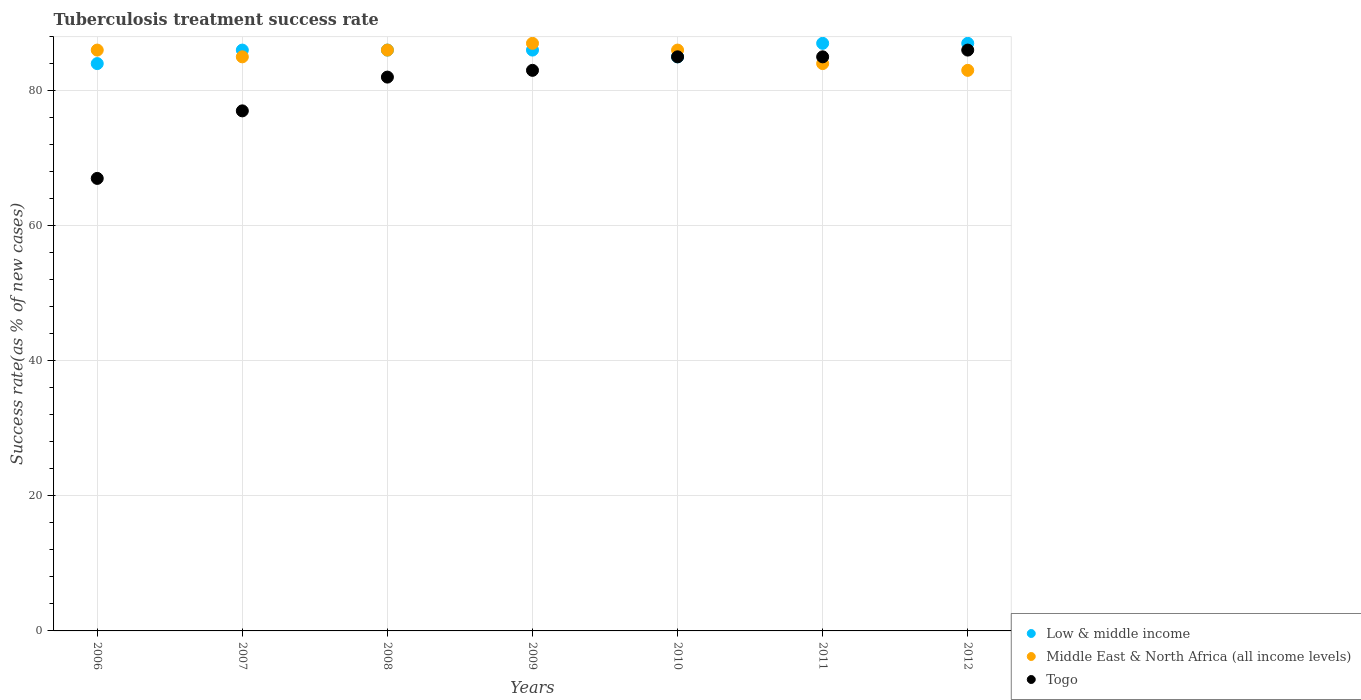How many different coloured dotlines are there?
Ensure brevity in your answer.  3. Is the number of dotlines equal to the number of legend labels?
Offer a very short reply. Yes. What is the tuberculosis treatment success rate in Low & middle income in 2012?
Keep it short and to the point. 87. Across all years, what is the maximum tuberculosis treatment success rate in Low & middle income?
Offer a terse response. 87. Across all years, what is the minimum tuberculosis treatment success rate in Low & middle income?
Provide a succinct answer. 84. In which year was the tuberculosis treatment success rate in Togo maximum?
Your answer should be very brief. 2012. In which year was the tuberculosis treatment success rate in Togo minimum?
Keep it short and to the point. 2006. What is the total tuberculosis treatment success rate in Middle East & North Africa (all income levels) in the graph?
Keep it short and to the point. 597. What is the difference between the tuberculosis treatment success rate in Middle East & North Africa (all income levels) in 2010 and that in 2012?
Your answer should be very brief. 3. What is the average tuberculosis treatment success rate in Togo per year?
Your answer should be very brief. 80.71. In the year 2006, what is the difference between the tuberculosis treatment success rate in Low & middle income and tuberculosis treatment success rate in Middle East & North Africa (all income levels)?
Your response must be concise. -2. In how many years, is the tuberculosis treatment success rate in Middle East & North Africa (all income levels) greater than 8 %?
Offer a very short reply. 7. What is the ratio of the tuberculosis treatment success rate in Togo in 2006 to that in 2012?
Your response must be concise. 0.78. Is the difference between the tuberculosis treatment success rate in Low & middle income in 2009 and 2012 greater than the difference between the tuberculosis treatment success rate in Middle East & North Africa (all income levels) in 2009 and 2012?
Give a very brief answer. No. What is the difference between the highest and the second highest tuberculosis treatment success rate in Togo?
Ensure brevity in your answer.  1. What is the difference between the highest and the lowest tuberculosis treatment success rate in Togo?
Make the answer very short. 19. Is it the case that in every year, the sum of the tuberculosis treatment success rate in Middle East & North Africa (all income levels) and tuberculosis treatment success rate in Low & middle income  is greater than the tuberculosis treatment success rate in Togo?
Give a very brief answer. Yes. Does the tuberculosis treatment success rate in Middle East & North Africa (all income levels) monotonically increase over the years?
Make the answer very short. No. Is the tuberculosis treatment success rate in Low & middle income strictly less than the tuberculosis treatment success rate in Togo over the years?
Keep it short and to the point. No. How many dotlines are there?
Your response must be concise. 3. Does the graph contain any zero values?
Give a very brief answer. No. Does the graph contain grids?
Provide a short and direct response. Yes. Where does the legend appear in the graph?
Your answer should be very brief. Bottom right. What is the title of the graph?
Give a very brief answer. Tuberculosis treatment success rate. Does "France" appear as one of the legend labels in the graph?
Give a very brief answer. No. What is the label or title of the Y-axis?
Provide a short and direct response. Success rate(as % of new cases). What is the Success rate(as % of new cases) in Low & middle income in 2006?
Your answer should be very brief. 84. What is the Success rate(as % of new cases) of Middle East & North Africa (all income levels) in 2006?
Provide a succinct answer. 86. What is the Success rate(as % of new cases) in Low & middle income in 2007?
Ensure brevity in your answer.  86. What is the Success rate(as % of new cases) in Middle East & North Africa (all income levels) in 2007?
Keep it short and to the point. 85. What is the Success rate(as % of new cases) of Middle East & North Africa (all income levels) in 2008?
Offer a very short reply. 86. What is the Success rate(as % of new cases) of Togo in 2008?
Make the answer very short. 82. What is the Success rate(as % of new cases) in Middle East & North Africa (all income levels) in 2009?
Keep it short and to the point. 87. What is the Success rate(as % of new cases) of Togo in 2009?
Your answer should be compact. 83. What is the Success rate(as % of new cases) of Middle East & North Africa (all income levels) in 2010?
Give a very brief answer. 86. What is the Success rate(as % of new cases) of Middle East & North Africa (all income levels) in 2011?
Offer a very short reply. 84. What is the Success rate(as % of new cases) in Togo in 2011?
Your response must be concise. 85. What is the Success rate(as % of new cases) in Low & middle income in 2012?
Provide a succinct answer. 87. What is the Success rate(as % of new cases) in Middle East & North Africa (all income levels) in 2012?
Make the answer very short. 83. Across all years, what is the maximum Success rate(as % of new cases) in Togo?
Give a very brief answer. 86. Across all years, what is the minimum Success rate(as % of new cases) in Low & middle income?
Make the answer very short. 84. Across all years, what is the minimum Success rate(as % of new cases) in Middle East & North Africa (all income levels)?
Provide a short and direct response. 83. What is the total Success rate(as % of new cases) in Low & middle income in the graph?
Make the answer very short. 601. What is the total Success rate(as % of new cases) of Middle East & North Africa (all income levels) in the graph?
Provide a short and direct response. 597. What is the total Success rate(as % of new cases) in Togo in the graph?
Your answer should be compact. 565. What is the difference between the Success rate(as % of new cases) of Low & middle income in 2006 and that in 2007?
Offer a very short reply. -2. What is the difference between the Success rate(as % of new cases) of Middle East & North Africa (all income levels) in 2006 and that in 2007?
Give a very brief answer. 1. What is the difference between the Success rate(as % of new cases) in Togo in 2006 and that in 2008?
Offer a very short reply. -15. What is the difference between the Success rate(as % of new cases) in Low & middle income in 2006 and that in 2010?
Provide a succinct answer. -1. What is the difference between the Success rate(as % of new cases) in Low & middle income in 2006 and that in 2011?
Provide a short and direct response. -3. What is the difference between the Success rate(as % of new cases) in Togo in 2006 and that in 2011?
Your response must be concise. -18. What is the difference between the Success rate(as % of new cases) in Middle East & North Africa (all income levels) in 2006 and that in 2012?
Ensure brevity in your answer.  3. What is the difference between the Success rate(as % of new cases) of Togo in 2006 and that in 2012?
Keep it short and to the point. -19. What is the difference between the Success rate(as % of new cases) in Middle East & North Africa (all income levels) in 2007 and that in 2009?
Your answer should be compact. -2. What is the difference between the Success rate(as % of new cases) of Togo in 2007 and that in 2010?
Provide a short and direct response. -8. What is the difference between the Success rate(as % of new cases) of Low & middle income in 2007 and that in 2011?
Provide a succinct answer. -1. What is the difference between the Success rate(as % of new cases) of Middle East & North Africa (all income levels) in 2007 and that in 2011?
Make the answer very short. 1. What is the difference between the Success rate(as % of new cases) of Togo in 2007 and that in 2011?
Keep it short and to the point. -8. What is the difference between the Success rate(as % of new cases) of Middle East & North Africa (all income levels) in 2007 and that in 2012?
Your answer should be very brief. 2. What is the difference between the Success rate(as % of new cases) in Low & middle income in 2008 and that in 2009?
Provide a short and direct response. 0. What is the difference between the Success rate(as % of new cases) of Togo in 2008 and that in 2009?
Your answer should be very brief. -1. What is the difference between the Success rate(as % of new cases) in Togo in 2008 and that in 2010?
Offer a very short reply. -3. What is the difference between the Success rate(as % of new cases) in Low & middle income in 2008 and that in 2011?
Offer a very short reply. -1. What is the difference between the Success rate(as % of new cases) in Middle East & North Africa (all income levels) in 2008 and that in 2011?
Your answer should be very brief. 2. What is the difference between the Success rate(as % of new cases) of Low & middle income in 2008 and that in 2012?
Offer a very short reply. -1. What is the difference between the Success rate(as % of new cases) in Middle East & North Africa (all income levels) in 2008 and that in 2012?
Offer a terse response. 3. What is the difference between the Success rate(as % of new cases) in Middle East & North Africa (all income levels) in 2009 and that in 2010?
Provide a succinct answer. 1. What is the difference between the Success rate(as % of new cases) in Togo in 2009 and that in 2010?
Provide a short and direct response. -2. What is the difference between the Success rate(as % of new cases) of Low & middle income in 2009 and that in 2011?
Your response must be concise. -1. What is the difference between the Success rate(as % of new cases) of Middle East & North Africa (all income levels) in 2009 and that in 2011?
Offer a very short reply. 3. What is the difference between the Success rate(as % of new cases) of Togo in 2009 and that in 2011?
Give a very brief answer. -2. What is the difference between the Success rate(as % of new cases) in Middle East & North Africa (all income levels) in 2009 and that in 2012?
Keep it short and to the point. 4. What is the difference between the Success rate(as % of new cases) in Togo in 2009 and that in 2012?
Provide a succinct answer. -3. What is the difference between the Success rate(as % of new cases) in Middle East & North Africa (all income levels) in 2010 and that in 2011?
Ensure brevity in your answer.  2. What is the difference between the Success rate(as % of new cases) of Low & middle income in 2010 and that in 2012?
Ensure brevity in your answer.  -2. What is the difference between the Success rate(as % of new cases) in Middle East & North Africa (all income levels) in 2011 and that in 2012?
Provide a succinct answer. 1. What is the difference between the Success rate(as % of new cases) in Low & middle income in 2006 and the Success rate(as % of new cases) in Togo in 2007?
Offer a very short reply. 7. What is the difference between the Success rate(as % of new cases) of Middle East & North Africa (all income levels) in 2006 and the Success rate(as % of new cases) of Togo in 2007?
Your answer should be very brief. 9. What is the difference between the Success rate(as % of new cases) in Low & middle income in 2006 and the Success rate(as % of new cases) in Middle East & North Africa (all income levels) in 2009?
Your answer should be compact. -3. What is the difference between the Success rate(as % of new cases) in Low & middle income in 2006 and the Success rate(as % of new cases) in Togo in 2009?
Your answer should be very brief. 1. What is the difference between the Success rate(as % of new cases) in Low & middle income in 2006 and the Success rate(as % of new cases) in Middle East & North Africa (all income levels) in 2010?
Ensure brevity in your answer.  -2. What is the difference between the Success rate(as % of new cases) of Low & middle income in 2006 and the Success rate(as % of new cases) of Togo in 2010?
Your answer should be compact. -1. What is the difference between the Success rate(as % of new cases) of Low & middle income in 2006 and the Success rate(as % of new cases) of Togo in 2011?
Give a very brief answer. -1. What is the difference between the Success rate(as % of new cases) in Middle East & North Africa (all income levels) in 2006 and the Success rate(as % of new cases) in Togo in 2011?
Your answer should be very brief. 1. What is the difference between the Success rate(as % of new cases) of Low & middle income in 2006 and the Success rate(as % of new cases) of Middle East & North Africa (all income levels) in 2012?
Provide a short and direct response. 1. What is the difference between the Success rate(as % of new cases) in Low & middle income in 2006 and the Success rate(as % of new cases) in Togo in 2012?
Offer a very short reply. -2. What is the difference between the Success rate(as % of new cases) in Middle East & North Africa (all income levels) in 2006 and the Success rate(as % of new cases) in Togo in 2012?
Your answer should be very brief. 0. What is the difference between the Success rate(as % of new cases) of Low & middle income in 2007 and the Success rate(as % of new cases) of Middle East & North Africa (all income levels) in 2008?
Make the answer very short. 0. What is the difference between the Success rate(as % of new cases) of Middle East & North Africa (all income levels) in 2007 and the Success rate(as % of new cases) of Togo in 2008?
Offer a terse response. 3. What is the difference between the Success rate(as % of new cases) of Low & middle income in 2007 and the Success rate(as % of new cases) of Middle East & North Africa (all income levels) in 2010?
Provide a short and direct response. 0. What is the difference between the Success rate(as % of new cases) in Low & middle income in 2007 and the Success rate(as % of new cases) in Togo in 2010?
Offer a very short reply. 1. What is the difference between the Success rate(as % of new cases) in Middle East & North Africa (all income levels) in 2007 and the Success rate(as % of new cases) in Togo in 2010?
Your answer should be very brief. 0. What is the difference between the Success rate(as % of new cases) of Low & middle income in 2007 and the Success rate(as % of new cases) of Togo in 2012?
Give a very brief answer. 0. What is the difference between the Success rate(as % of new cases) of Low & middle income in 2008 and the Success rate(as % of new cases) of Middle East & North Africa (all income levels) in 2009?
Your answer should be compact. -1. What is the difference between the Success rate(as % of new cases) in Middle East & North Africa (all income levels) in 2008 and the Success rate(as % of new cases) in Togo in 2009?
Provide a succinct answer. 3. What is the difference between the Success rate(as % of new cases) in Low & middle income in 2008 and the Success rate(as % of new cases) in Middle East & North Africa (all income levels) in 2010?
Your response must be concise. 0. What is the difference between the Success rate(as % of new cases) in Low & middle income in 2008 and the Success rate(as % of new cases) in Togo in 2010?
Provide a short and direct response. 1. What is the difference between the Success rate(as % of new cases) in Middle East & North Africa (all income levels) in 2008 and the Success rate(as % of new cases) in Togo in 2010?
Provide a short and direct response. 1. What is the difference between the Success rate(as % of new cases) of Low & middle income in 2008 and the Success rate(as % of new cases) of Togo in 2011?
Give a very brief answer. 1. What is the difference between the Success rate(as % of new cases) of Middle East & North Africa (all income levels) in 2008 and the Success rate(as % of new cases) of Togo in 2011?
Make the answer very short. 1. What is the difference between the Success rate(as % of new cases) in Middle East & North Africa (all income levels) in 2008 and the Success rate(as % of new cases) in Togo in 2012?
Provide a short and direct response. 0. What is the difference between the Success rate(as % of new cases) of Low & middle income in 2009 and the Success rate(as % of new cases) of Togo in 2010?
Offer a terse response. 1. What is the difference between the Success rate(as % of new cases) in Middle East & North Africa (all income levels) in 2009 and the Success rate(as % of new cases) in Togo in 2010?
Give a very brief answer. 2. What is the difference between the Success rate(as % of new cases) of Low & middle income in 2009 and the Success rate(as % of new cases) of Togo in 2011?
Keep it short and to the point. 1. What is the difference between the Success rate(as % of new cases) of Middle East & North Africa (all income levels) in 2010 and the Success rate(as % of new cases) of Togo in 2012?
Provide a short and direct response. 0. What is the difference between the Success rate(as % of new cases) in Low & middle income in 2011 and the Success rate(as % of new cases) in Middle East & North Africa (all income levels) in 2012?
Your answer should be very brief. 4. What is the difference between the Success rate(as % of new cases) in Low & middle income in 2011 and the Success rate(as % of new cases) in Togo in 2012?
Your answer should be compact. 1. What is the difference between the Success rate(as % of new cases) in Middle East & North Africa (all income levels) in 2011 and the Success rate(as % of new cases) in Togo in 2012?
Offer a terse response. -2. What is the average Success rate(as % of new cases) in Low & middle income per year?
Your answer should be very brief. 85.86. What is the average Success rate(as % of new cases) in Middle East & North Africa (all income levels) per year?
Your response must be concise. 85.29. What is the average Success rate(as % of new cases) in Togo per year?
Your answer should be very brief. 80.71. In the year 2006, what is the difference between the Success rate(as % of new cases) of Low & middle income and Success rate(as % of new cases) of Togo?
Provide a succinct answer. 17. In the year 2006, what is the difference between the Success rate(as % of new cases) in Middle East & North Africa (all income levels) and Success rate(as % of new cases) in Togo?
Make the answer very short. 19. In the year 2007, what is the difference between the Success rate(as % of new cases) in Low & middle income and Success rate(as % of new cases) in Middle East & North Africa (all income levels)?
Ensure brevity in your answer.  1. In the year 2007, what is the difference between the Success rate(as % of new cases) in Low & middle income and Success rate(as % of new cases) in Togo?
Keep it short and to the point. 9. In the year 2008, what is the difference between the Success rate(as % of new cases) in Low & middle income and Success rate(as % of new cases) in Togo?
Make the answer very short. 4. In the year 2008, what is the difference between the Success rate(as % of new cases) of Middle East & North Africa (all income levels) and Success rate(as % of new cases) of Togo?
Your response must be concise. 4. In the year 2009, what is the difference between the Success rate(as % of new cases) in Low & middle income and Success rate(as % of new cases) in Middle East & North Africa (all income levels)?
Provide a succinct answer. -1. In the year 2009, what is the difference between the Success rate(as % of new cases) of Low & middle income and Success rate(as % of new cases) of Togo?
Your answer should be compact. 3. In the year 2010, what is the difference between the Success rate(as % of new cases) in Low & middle income and Success rate(as % of new cases) in Togo?
Your answer should be compact. 0. In the year 2010, what is the difference between the Success rate(as % of new cases) of Middle East & North Africa (all income levels) and Success rate(as % of new cases) of Togo?
Offer a very short reply. 1. In the year 2011, what is the difference between the Success rate(as % of new cases) of Low & middle income and Success rate(as % of new cases) of Middle East & North Africa (all income levels)?
Make the answer very short. 3. In the year 2012, what is the difference between the Success rate(as % of new cases) in Low & middle income and Success rate(as % of new cases) in Togo?
Give a very brief answer. 1. What is the ratio of the Success rate(as % of new cases) in Low & middle income in 2006 to that in 2007?
Offer a very short reply. 0.98. What is the ratio of the Success rate(as % of new cases) of Middle East & North Africa (all income levels) in 2006 to that in 2007?
Provide a short and direct response. 1.01. What is the ratio of the Success rate(as % of new cases) of Togo in 2006 to that in 2007?
Offer a terse response. 0.87. What is the ratio of the Success rate(as % of new cases) of Low & middle income in 2006 to that in 2008?
Provide a succinct answer. 0.98. What is the ratio of the Success rate(as % of new cases) in Middle East & North Africa (all income levels) in 2006 to that in 2008?
Ensure brevity in your answer.  1. What is the ratio of the Success rate(as % of new cases) of Togo in 2006 to that in 2008?
Provide a succinct answer. 0.82. What is the ratio of the Success rate(as % of new cases) in Low & middle income in 2006 to that in 2009?
Offer a terse response. 0.98. What is the ratio of the Success rate(as % of new cases) in Middle East & North Africa (all income levels) in 2006 to that in 2009?
Provide a succinct answer. 0.99. What is the ratio of the Success rate(as % of new cases) in Togo in 2006 to that in 2009?
Your answer should be compact. 0.81. What is the ratio of the Success rate(as % of new cases) of Togo in 2006 to that in 2010?
Provide a succinct answer. 0.79. What is the ratio of the Success rate(as % of new cases) of Low & middle income in 2006 to that in 2011?
Offer a very short reply. 0.97. What is the ratio of the Success rate(as % of new cases) in Middle East & North Africa (all income levels) in 2006 to that in 2011?
Keep it short and to the point. 1.02. What is the ratio of the Success rate(as % of new cases) in Togo in 2006 to that in 2011?
Offer a very short reply. 0.79. What is the ratio of the Success rate(as % of new cases) in Low & middle income in 2006 to that in 2012?
Ensure brevity in your answer.  0.97. What is the ratio of the Success rate(as % of new cases) of Middle East & North Africa (all income levels) in 2006 to that in 2012?
Keep it short and to the point. 1.04. What is the ratio of the Success rate(as % of new cases) of Togo in 2006 to that in 2012?
Provide a short and direct response. 0.78. What is the ratio of the Success rate(as % of new cases) of Low & middle income in 2007 to that in 2008?
Make the answer very short. 1. What is the ratio of the Success rate(as % of new cases) of Middle East & North Africa (all income levels) in 2007 to that in 2008?
Your response must be concise. 0.99. What is the ratio of the Success rate(as % of new cases) in Togo in 2007 to that in 2008?
Offer a very short reply. 0.94. What is the ratio of the Success rate(as % of new cases) of Low & middle income in 2007 to that in 2009?
Provide a succinct answer. 1. What is the ratio of the Success rate(as % of new cases) of Middle East & North Africa (all income levels) in 2007 to that in 2009?
Ensure brevity in your answer.  0.98. What is the ratio of the Success rate(as % of new cases) in Togo in 2007 to that in 2009?
Make the answer very short. 0.93. What is the ratio of the Success rate(as % of new cases) in Low & middle income in 2007 to that in 2010?
Offer a very short reply. 1.01. What is the ratio of the Success rate(as % of new cases) of Middle East & North Africa (all income levels) in 2007 to that in 2010?
Your answer should be compact. 0.99. What is the ratio of the Success rate(as % of new cases) of Togo in 2007 to that in 2010?
Provide a succinct answer. 0.91. What is the ratio of the Success rate(as % of new cases) of Low & middle income in 2007 to that in 2011?
Your answer should be compact. 0.99. What is the ratio of the Success rate(as % of new cases) in Middle East & North Africa (all income levels) in 2007 to that in 2011?
Your response must be concise. 1.01. What is the ratio of the Success rate(as % of new cases) in Togo in 2007 to that in 2011?
Keep it short and to the point. 0.91. What is the ratio of the Success rate(as % of new cases) in Middle East & North Africa (all income levels) in 2007 to that in 2012?
Your response must be concise. 1.02. What is the ratio of the Success rate(as % of new cases) in Togo in 2007 to that in 2012?
Offer a terse response. 0.9. What is the ratio of the Success rate(as % of new cases) in Togo in 2008 to that in 2009?
Keep it short and to the point. 0.99. What is the ratio of the Success rate(as % of new cases) of Low & middle income in 2008 to that in 2010?
Give a very brief answer. 1.01. What is the ratio of the Success rate(as % of new cases) in Togo in 2008 to that in 2010?
Your answer should be very brief. 0.96. What is the ratio of the Success rate(as % of new cases) of Low & middle income in 2008 to that in 2011?
Offer a very short reply. 0.99. What is the ratio of the Success rate(as % of new cases) in Middle East & North Africa (all income levels) in 2008 to that in 2011?
Provide a short and direct response. 1.02. What is the ratio of the Success rate(as % of new cases) in Togo in 2008 to that in 2011?
Ensure brevity in your answer.  0.96. What is the ratio of the Success rate(as % of new cases) in Middle East & North Africa (all income levels) in 2008 to that in 2012?
Your response must be concise. 1.04. What is the ratio of the Success rate(as % of new cases) in Togo in 2008 to that in 2012?
Your response must be concise. 0.95. What is the ratio of the Success rate(as % of new cases) in Low & middle income in 2009 to that in 2010?
Make the answer very short. 1.01. What is the ratio of the Success rate(as % of new cases) in Middle East & North Africa (all income levels) in 2009 to that in 2010?
Offer a terse response. 1.01. What is the ratio of the Success rate(as % of new cases) of Togo in 2009 to that in 2010?
Your response must be concise. 0.98. What is the ratio of the Success rate(as % of new cases) of Middle East & North Africa (all income levels) in 2009 to that in 2011?
Keep it short and to the point. 1.04. What is the ratio of the Success rate(as % of new cases) in Togo in 2009 to that in 2011?
Your answer should be compact. 0.98. What is the ratio of the Success rate(as % of new cases) in Low & middle income in 2009 to that in 2012?
Make the answer very short. 0.99. What is the ratio of the Success rate(as % of new cases) in Middle East & North Africa (all income levels) in 2009 to that in 2012?
Provide a succinct answer. 1.05. What is the ratio of the Success rate(as % of new cases) of Togo in 2009 to that in 2012?
Your answer should be compact. 0.97. What is the ratio of the Success rate(as % of new cases) in Low & middle income in 2010 to that in 2011?
Your answer should be compact. 0.98. What is the ratio of the Success rate(as % of new cases) of Middle East & North Africa (all income levels) in 2010 to that in 2011?
Your response must be concise. 1.02. What is the ratio of the Success rate(as % of new cases) in Togo in 2010 to that in 2011?
Offer a very short reply. 1. What is the ratio of the Success rate(as % of new cases) of Low & middle income in 2010 to that in 2012?
Give a very brief answer. 0.98. What is the ratio of the Success rate(as % of new cases) in Middle East & North Africa (all income levels) in 2010 to that in 2012?
Ensure brevity in your answer.  1.04. What is the ratio of the Success rate(as % of new cases) in Togo in 2010 to that in 2012?
Offer a terse response. 0.99. What is the ratio of the Success rate(as % of new cases) in Togo in 2011 to that in 2012?
Your answer should be compact. 0.99. What is the difference between the highest and the second highest Success rate(as % of new cases) in Low & middle income?
Your response must be concise. 0. What is the difference between the highest and the second highest Success rate(as % of new cases) in Middle East & North Africa (all income levels)?
Offer a very short reply. 1. What is the difference between the highest and the lowest Success rate(as % of new cases) of Low & middle income?
Offer a very short reply. 3. What is the difference between the highest and the lowest Success rate(as % of new cases) of Togo?
Keep it short and to the point. 19. 